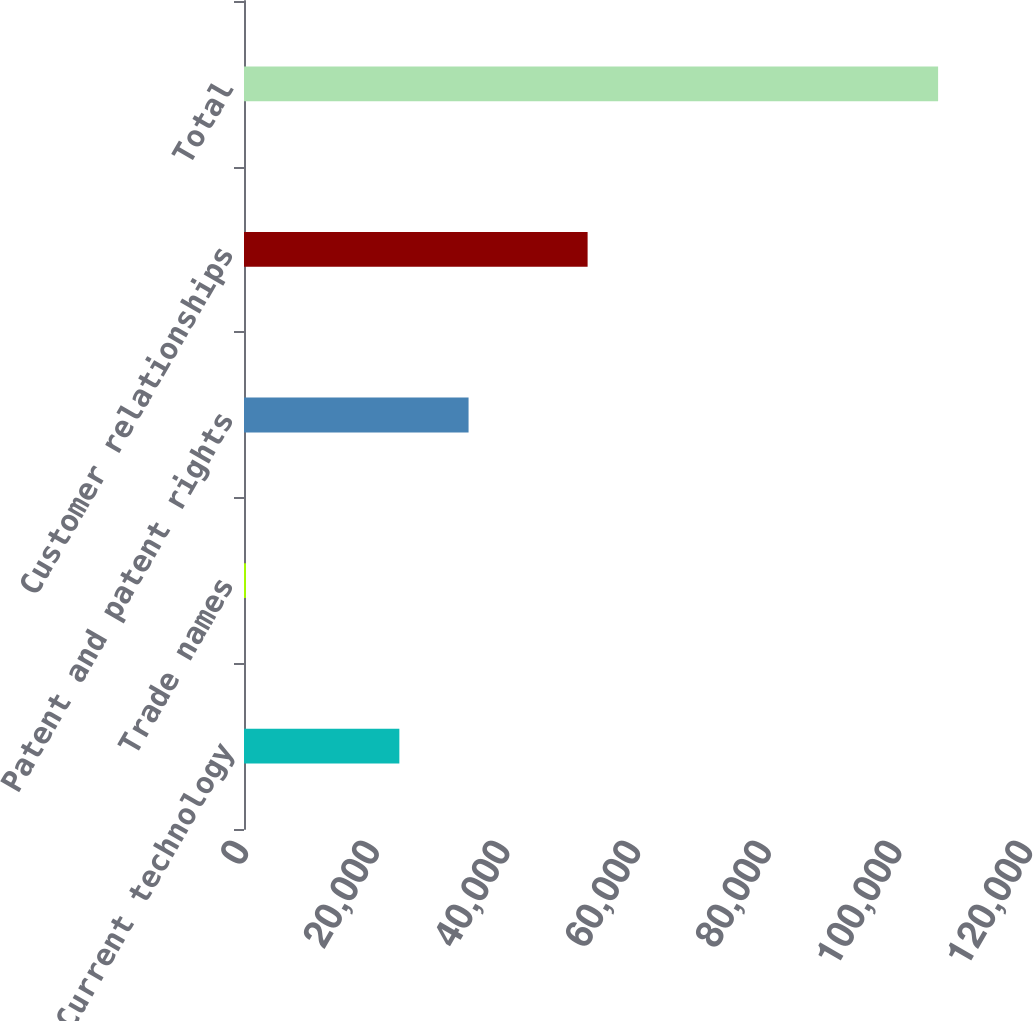Convert chart. <chart><loc_0><loc_0><loc_500><loc_500><bar_chart><fcel>Current technology<fcel>Trade names<fcel>Patent and patent rights<fcel>Customer relationships<fcel>Total<nl><fcel>23778<fcel>300<fcel>34372<fcel>52593<fcel>106240<nl></chart> 